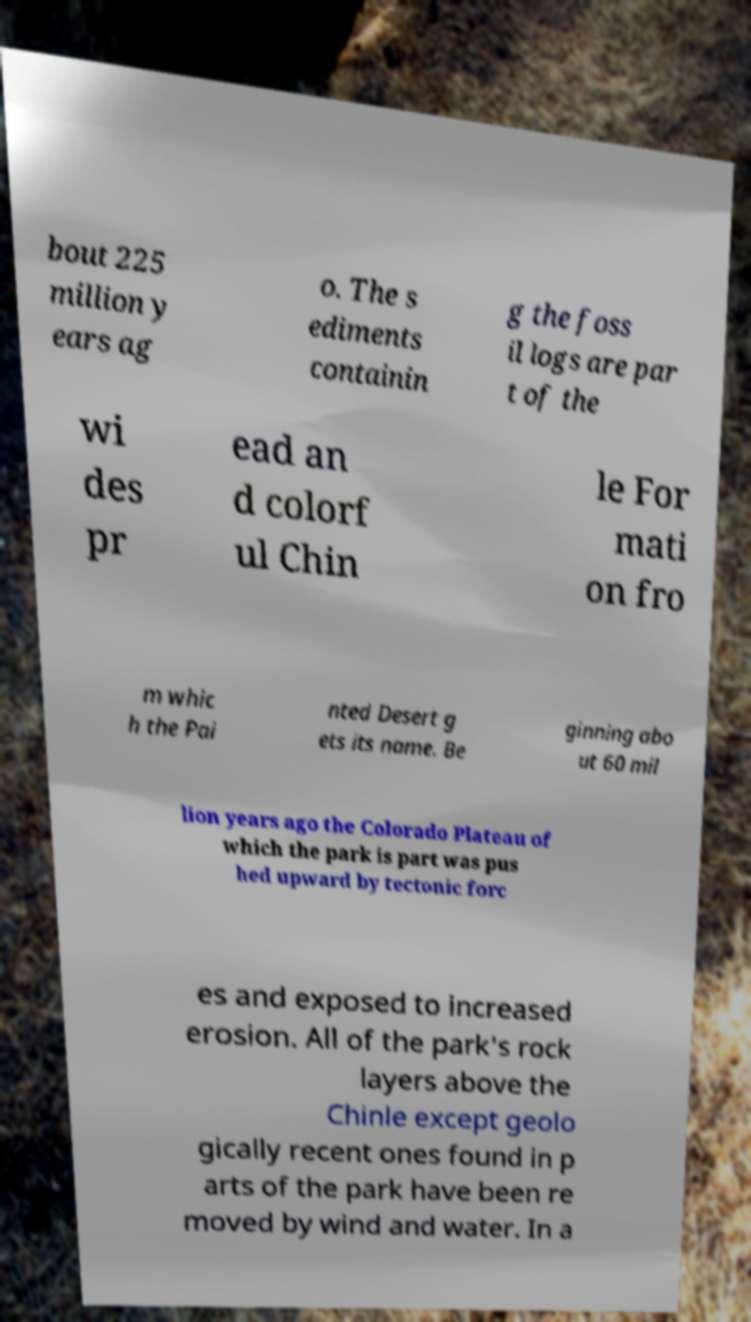Can you accurately transcribe the text from the provided image for me? bout 225 million y ears ag o. The s ediments containin g the foss il logs are par t of the wi des pr ead an d colorf ul Chin le For mati on fro m whic h the Pai nted Desert g ets its name. Be ginning abo ut 60 mil lion years ago the Colorado Plateau of which the park is part was pus hed upward by tectonic forc es and exposed to increased erosion. All of the park's rock layers above the Chinle except geolo gically recent ones found in p arts of the park have been re moved by wind and water. In a 